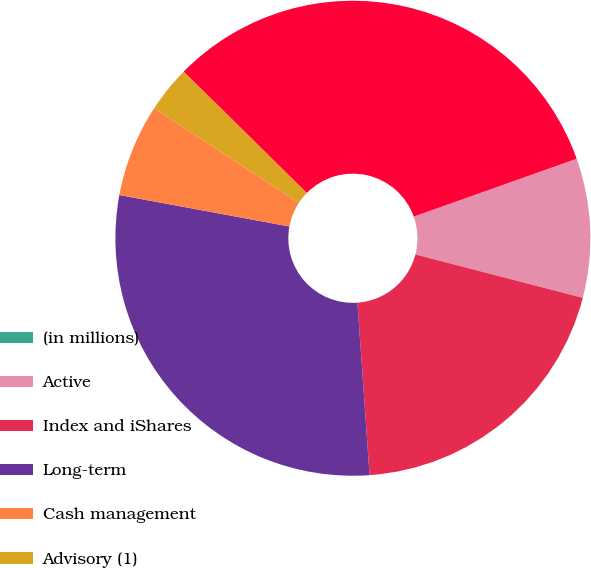Convert chart to OTSL. <chart><loc_0><loc_0><loc_500><loc_500><pie_chart><fcel>(in millions)<fcel>Active<fcel>Index and iShares<fcel>Long-term<fcel>Cash management<fcel>Advisory (1)<fcel>Total<nl><fcel>0.01%<fcel>9.46%<fcel>19.84%<fcel>29.03%<fcel>6.31%<fcel>3.16%<fcel>32.18%<nl></chart> 